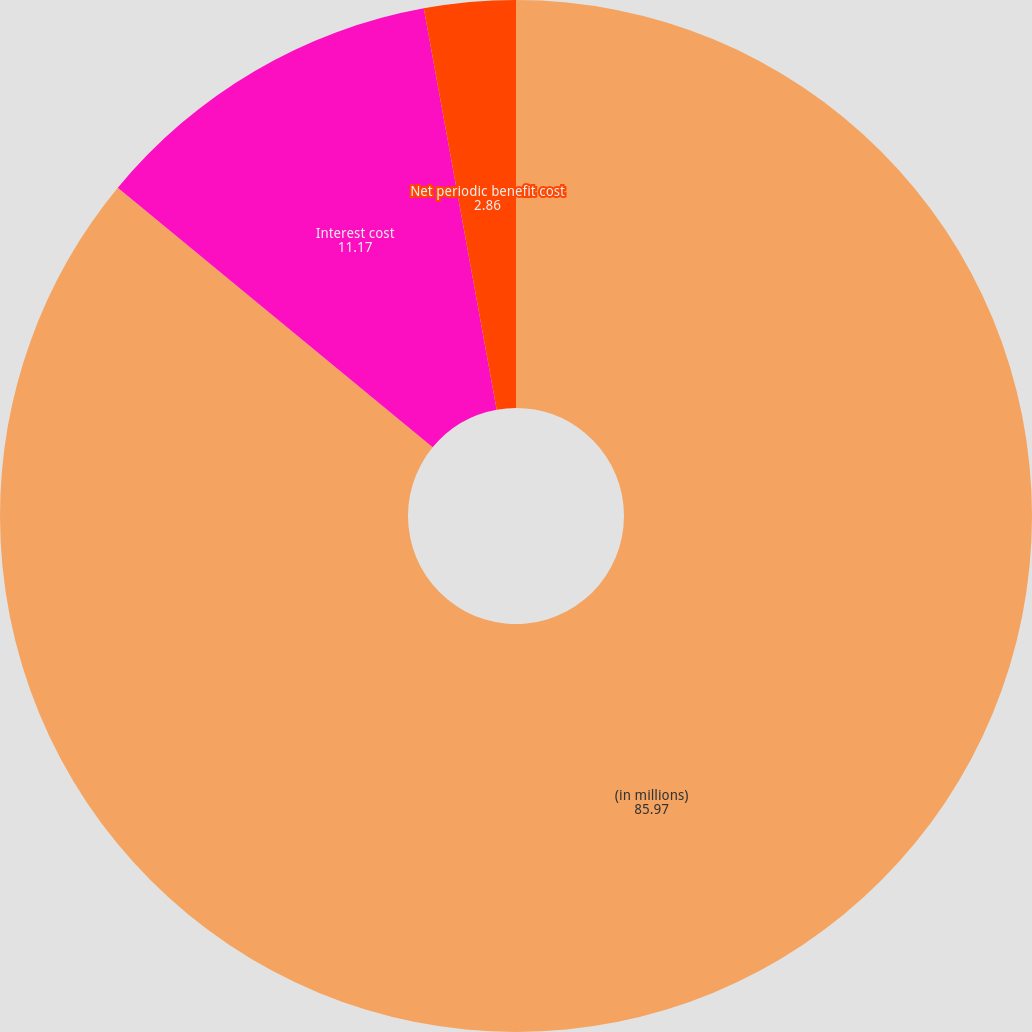Convert chart to OTSL. <chart><loc_0><loc_0><loc_500><loc_500><pie_chart><fcel>(in millions)<fcel>Interest cost<fcel>Net periodic benefit cost<nl><fcel>85.97%<fcel>11.17%<fcel>2.86%<nl></chart> 